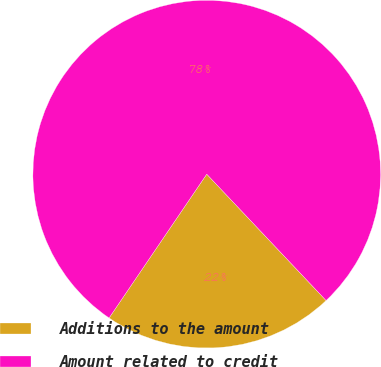Convert chart to OTSL. <chart><loc_0><loc_0><loc_500><loc_500><pie_chart><fcel>Additions to the amount<fcel>Amount related to credit<nl><fcel>21.54%<fcel>78.46%<nl></chart> 